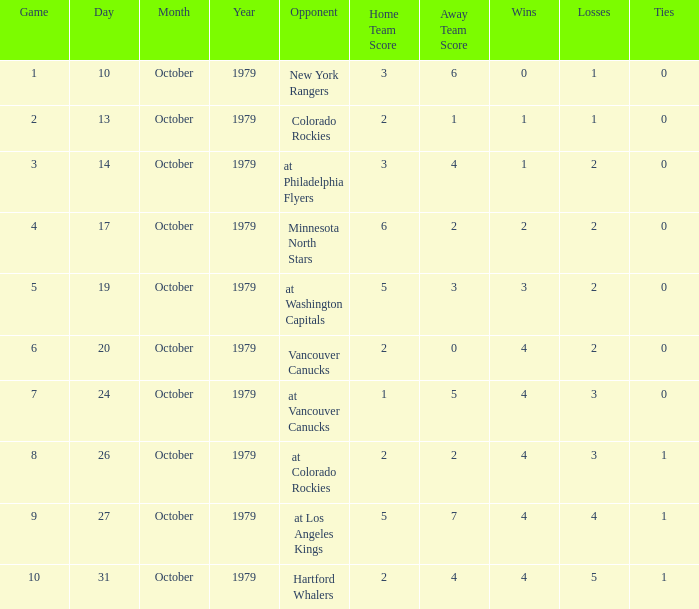Who is the opponent before game 5 with a 0-1-0 record? New York Rangers. 